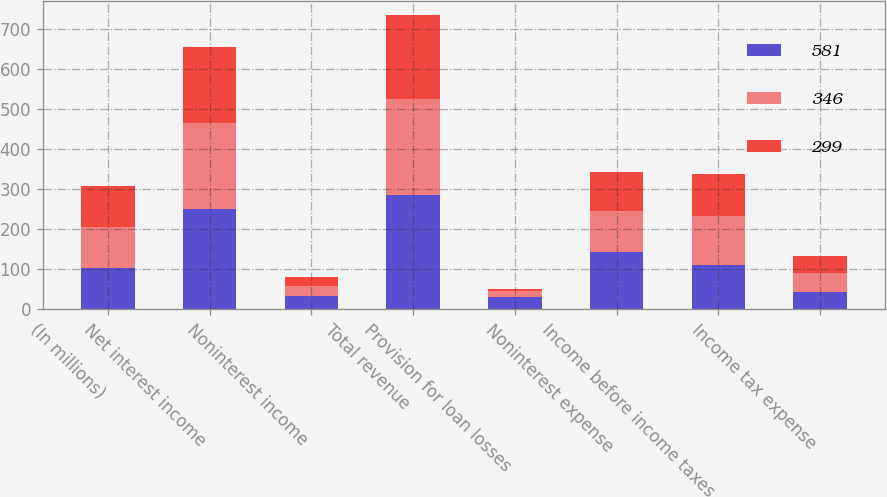Convert chart to OTSL. <chart><loc_0><loc_0><loc_500><loc_500><stacked_bar_chart><ecel><fcel>(In millions)<fcel>Net interest income<fcel>Noninterest income<fcel>Total revenue<fcel>Provision for loan losses<fcel>Noninterest expense<fcel>Income before income taxes<fcel>Income tax expense<nl><fcel>581<fcel>103<fcel>250.8<fcel>33.4<fcel>284.2<fcel>30.5<fcel>142.4<fcel>111.3<fcel>43.5<nl><fcel>346<fcel>103<fcel>214.9<fcel>25.4<fcel>240.3<fcel>16.3<fcel>103<fcel>121<fcel>47.8<nl><fcel>299<fcel>103<fcel>187.6<fcel>21.5<fcel>209.1<fcel>5.2<fcel>97.8<fcel>106.1<fcel>42.1<nl></chart> 